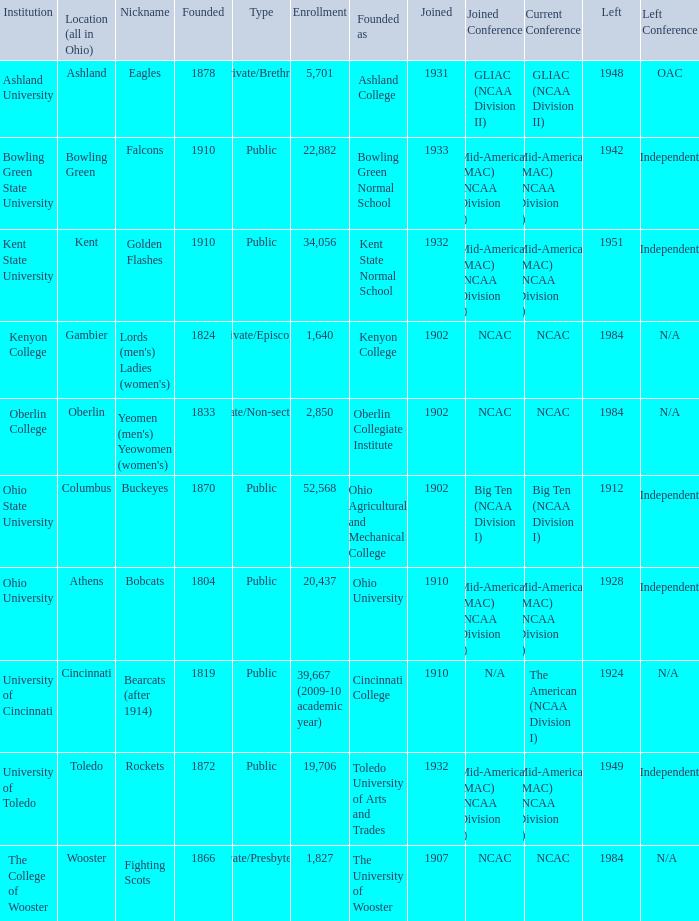Which founding year corresponds with the highest enrollment?  1910.0. 